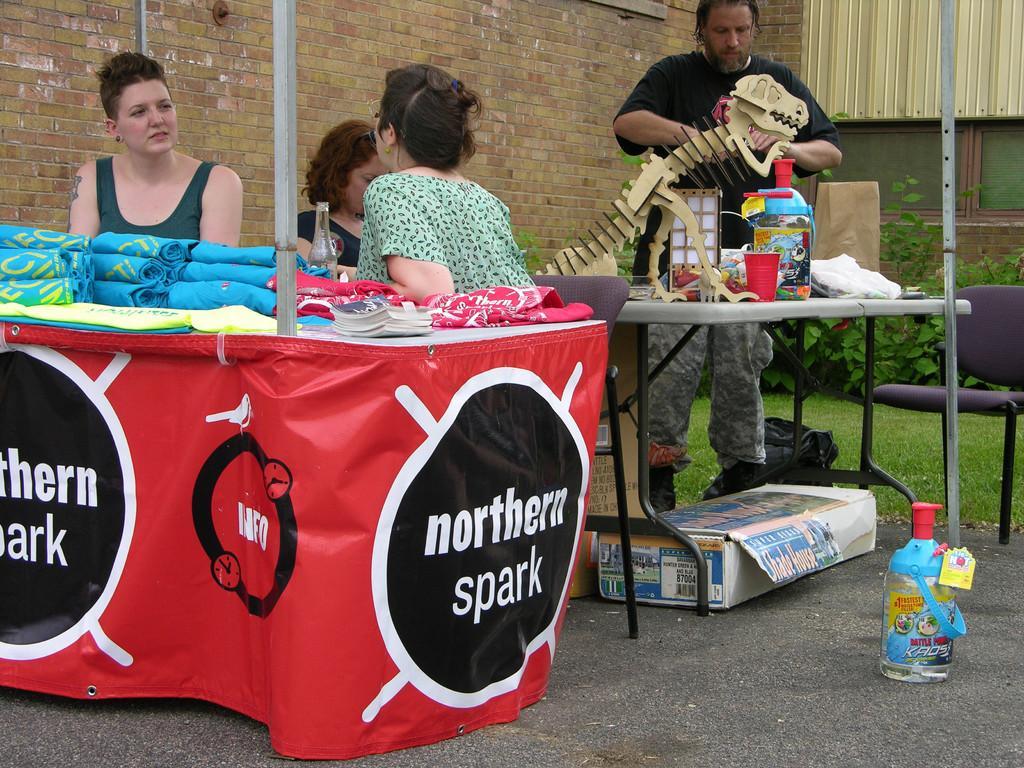How would you summarize this image in a sentence or two? In this picture there are three women sitting in chair and there is a table in front of them and there is a banner attached to it which has northern spark written on it and there is a table behind them which has few other objects on it and there is a person standing behind it and there are few plants and a building in the background. 